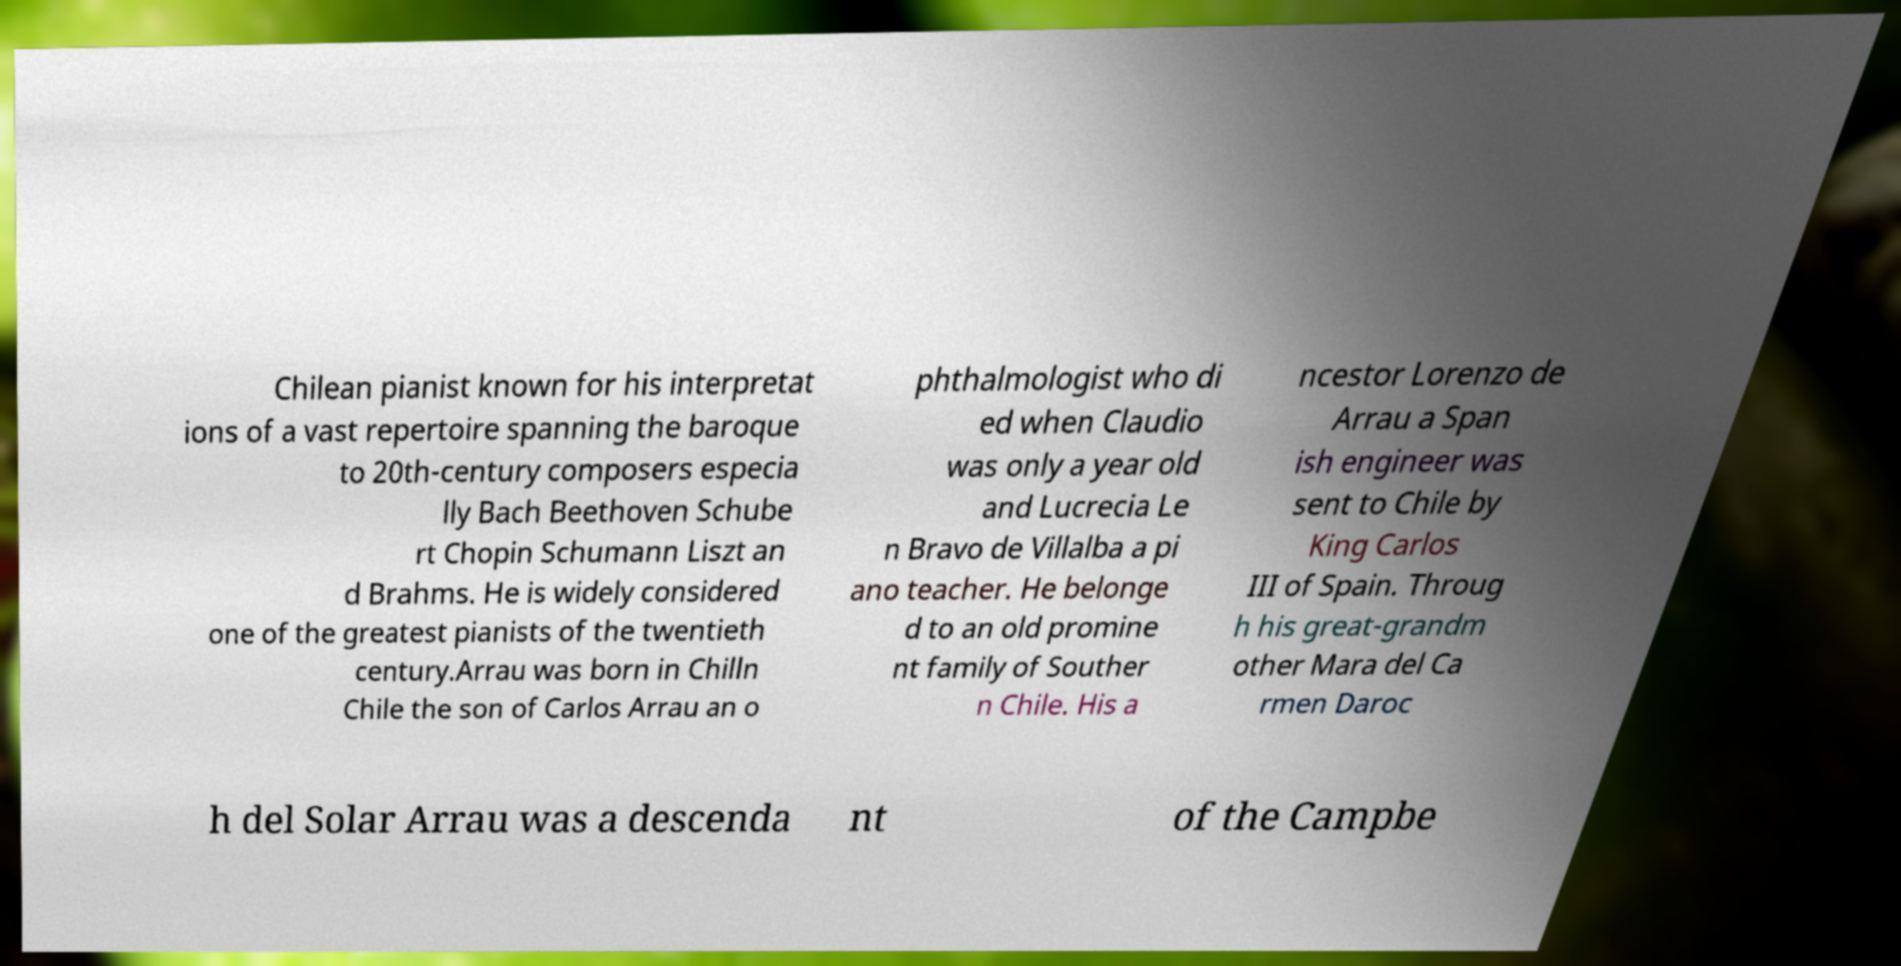There's text embedded in this image that I need extracted. Can you transcribe it verbatim? Chilean pianist known for his interpretat ions of a vast repertoire spanning the baroque to 20th-century composers especia lly Bach Beethoven Schube rt Chopin Schumann Liszt an d Brahms. He is widely considered one of the greatest pianists of the twentieth century.Arrau was born in Chilln Chile the son of Carlos Arrau an o phthalmologist who di ed when Claudio was only a year old and Lucrecia Le n Bravo de Villalba a pi ano teacher. He belonge d to an old promine nt family of Souther n Chile. His a ncestor Lorenzo de Arrau a Span ish engineer was sent to Chile by King Carlos III of Spain. Throug h his great-grandm other Mara del Ca rmen Daroc h del Solar Arrau was a descenda nt of the Campbe 